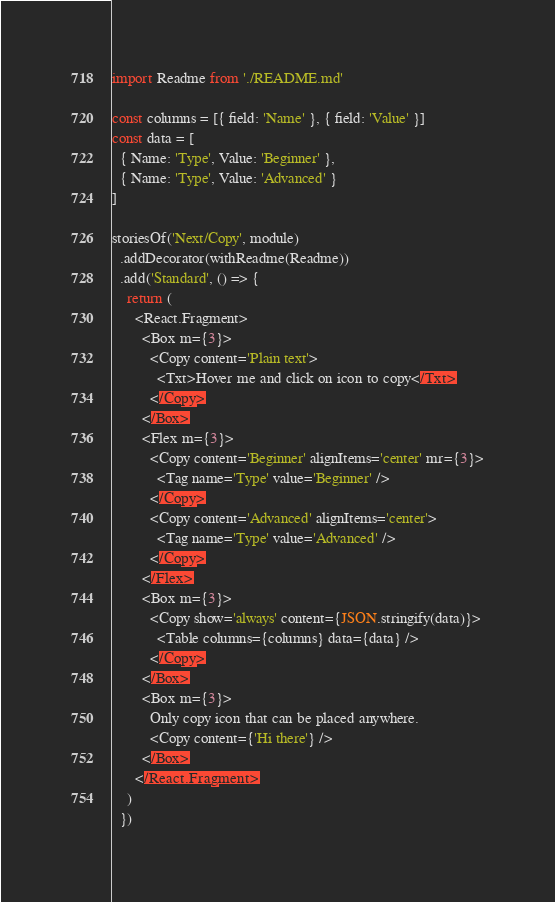Convert code to text. <code><loc_0><loc_0><loc_500><loc_500><_JavaScript_>import Readme from './README.md'

const columns = [{ field: 'Name' }, { field: 'Value' }]
const data = [
  { Name: 'Type', Value: 'Beginner' },
  { Name: 'Type', Value: 'Advanced' }
]

storiesOf('Next/Copy', module)
  .addDecorator(withReadme(Readme))
  .add('Standard', () => {
    return (
      <React.Fragment>
        <Box m={3}>
          <Copy content='Plain text'>
            <Txt>Hover me and click on icon to copy</Txt>
          </Copy>
        </Box>
        <Flex m={3}>
          <Copy content='Beginner' alignItems='center' mr={3}>
            <Tag name='Type' value='Beginner' />
          </Copy>
          <Copy content='Advanced' alignItems='center'>
            <Tag name='Type' value='Advanced' />
          </Copy>
        </Flex>
        <Box m={3}>
          <Copy show='always' content={JSON.stringify(data)}>
            <Table columns={columns} data={data} />
          </Copy>
        </Box>
        <Box m={3}>
          Only copy icon that can be placed anywhere.
          <Copy content={'Hi there'} />
        </Box>
      </React.Fragment>
    )
  })
</code> 